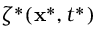<formula> <loc_0><loc_0><loc_500><loc_500>\zeta ^ { * } ( x ^ { * } , t ^ { * } )</formula> 